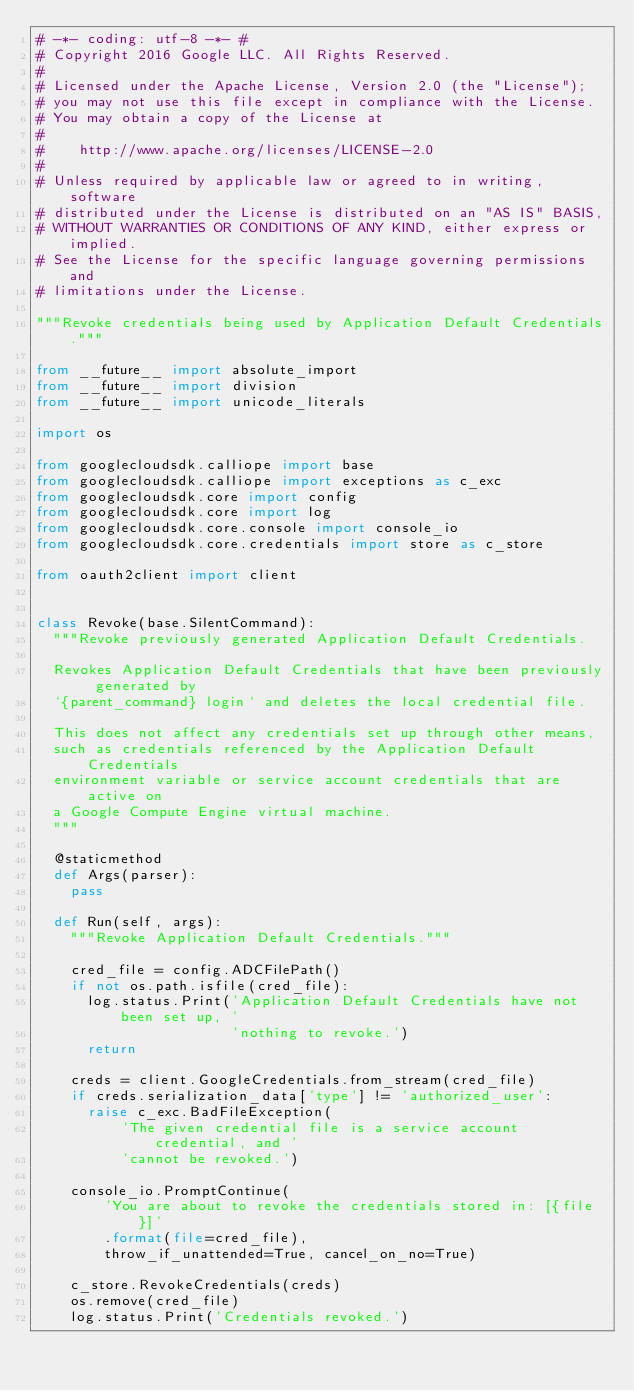<code> <loc_0><loc_0><loc_500><loc_500><_Python_># -*- coding: utf-8 -*- #
# Copyright 2016 Google LLC. All Rights Reserved.
#
# Licensed under the Apache License, Version 2.0 (the "License");
# you may not use this file except in compliance with the License.
# You may obtain a copy of the License at
#
#    http://www.apache.org/licenses/LICENSE-2.0
#
# Unless required by applicable law or agreed to in writing, software
# distributed under the License is distributed on an "AS IS" BASIS,
# WITHOUT WARRANTIES OR CONDITIONS OF ANY KIND, either express or implied.
# See the License for the specific language governing permissions and
# limitations under the License.

"""Revoke credentials being used by Application Default Credentials."""

from __future__ import absolute_import
from __future__ import division
from __future__ import unicode_literals

import os

from googlecloudsdk.calliope import base
from googlecloudsdk.calliope import exceptions as c_exc
from googlecloudsdk.core import config
from googlecloudsdk.core import log
from googlecloudsdk.core.console import console_io
from googlecloudsdk.core.credentials import store as c_store

from oauth2client import client


class Revoke(base.SilentCommand):
  """Revoke previously generated Application Default Credentials.

  Revokes Application Default Credentials that have been previously generated by
  `{parent_command} login` and deletes the local credential file.

  This does not affect any credentials set up through other means,
  such as credentials referenced by the Application Default Credentials
  environment variable or service account credentials that are active on
  a Google Compute Engine virtual machine.
  """

  @staticmethod
  def Args(parser):
    pass

  def Run(self, args):
    """Revoke Application Default Credentials."""

    cred_file = config.ADCFilePath()
    if not os.path.isfile(cred_file):
      log.status.Print('Application Default Credentials have not been set up, '
                       'nothing to revoke.')
      return

    creds = client.GoogleCredentials.from_stream(cred_file)
    if creds.serialization_data['type'] != 'authorized_user':
      raise c_exc.BadFileException(
          'The given credential file is a service account credential, and '
          'cannot be revoked.')

    console_io.PromptContinue(
        'You are about to revoke the credentials stored in: [{file}]'
        .format(file=cred_file),
        throw_if_unattended=True, cancel_on_no=True)

    c_store.RevokeCredentials(creds)
    os.remove(cred_file)
    log.status.Print('Credentials revoked.')
</code> 